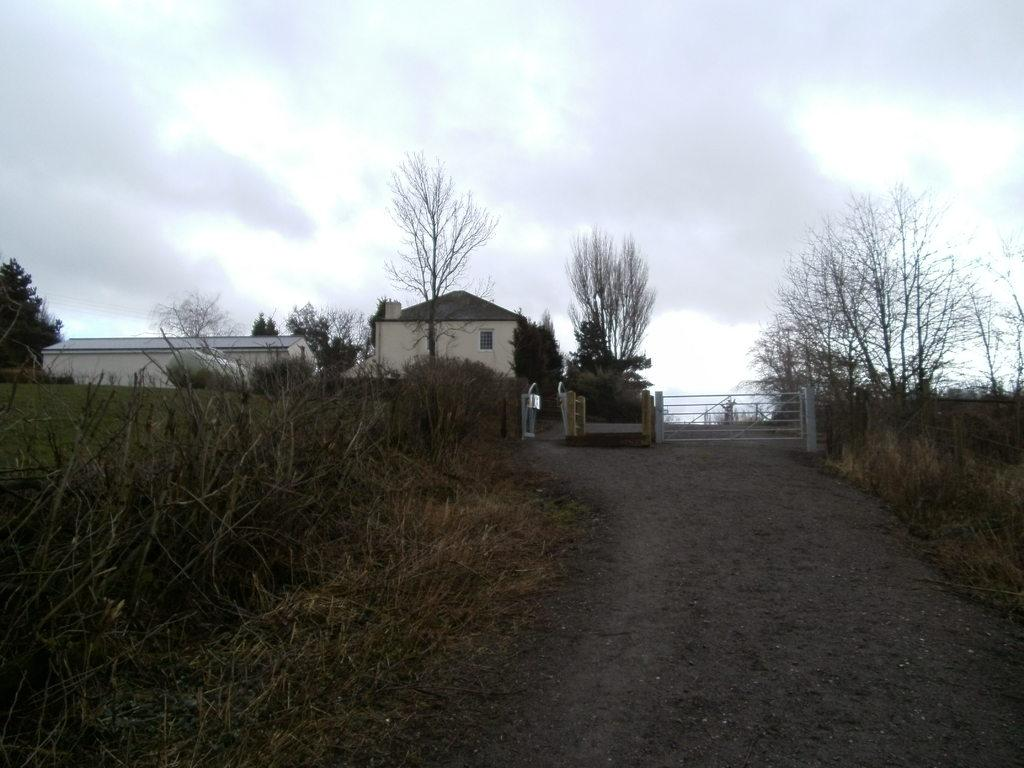What type of vegetation is on the left side of the image? There are plants on the left side of the image. What can be seen in the background of the image? There are buildings, trees, a gate, and the sky visible in the background of the image. What type of pathway is present in the image? There is a road on the side of the image. Can you hear the robin singing in the image? There is no robin present in the image, so it is not possible to hear it singing. What type of noise is coming from the sky in the image? There is no noise coming from the sky in the image; it is simply visible in the background. 